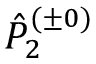<formula> <loc_0><loc_0><loc_500><loc_500>\hat { P } _ { 2 } ^ { ( \pm 0 ) }</formula> 